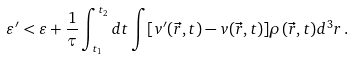Convert formula to latex. <formula><loc_0><loc_0><loc_500><loc_500>\varepsilon ^ { \prime } < \varepsilon + \frac { 1 } { \tau } \int _ { t _ { 1 } } ^ { t _ { 2 } } d t \int [ v ^ { \prime } ( \vec { r } , t ) - v ( \vec { r } , t ) ] \rho ( \vec { r } , t ) d ^ { 3 } r \, .</formula> 